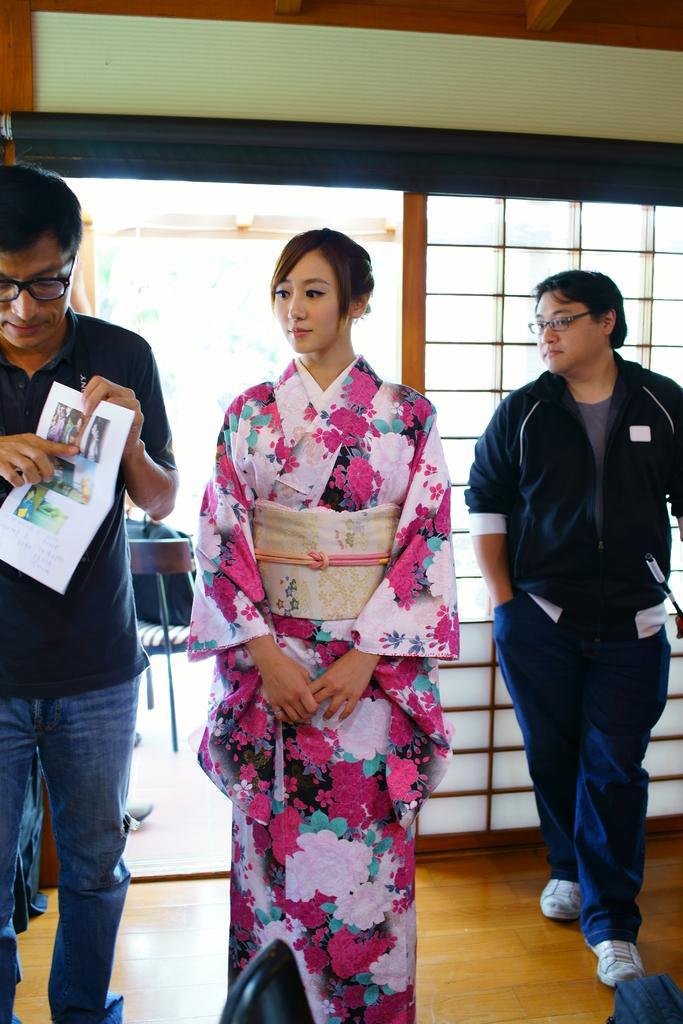Describe this image in one or two sentences. This picture shows few people standing and we see a woman and a man holding papers in his hand and we see both men wore spectacles on their faces and we see a chair and a bag on it. 